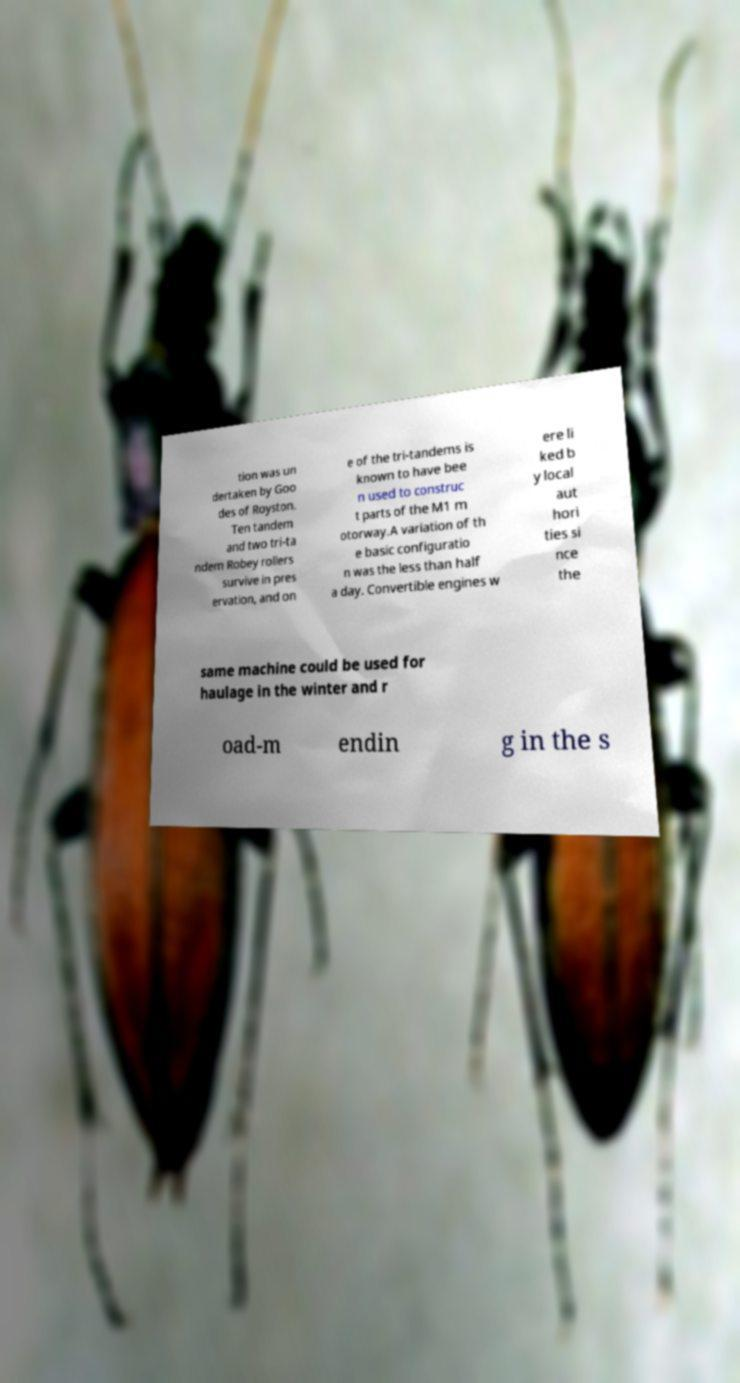Could you assist in decoding the text presented in this image and type it out clearly? tion was un dertaken by Goo des of Royston. Ten tandem and two tri-ta ndem Robey rollers survive in pres ervation, and on e of the tri-tandems is known to have bee n used to construc t parts of the M1 m otorway.A variation of th e basic configuratio n was the less than half a day. Convertible engines w ere li ked b y local aut hori ties si nce the same machine could be used for haulage in the winter and r oad-m endin g in the s 